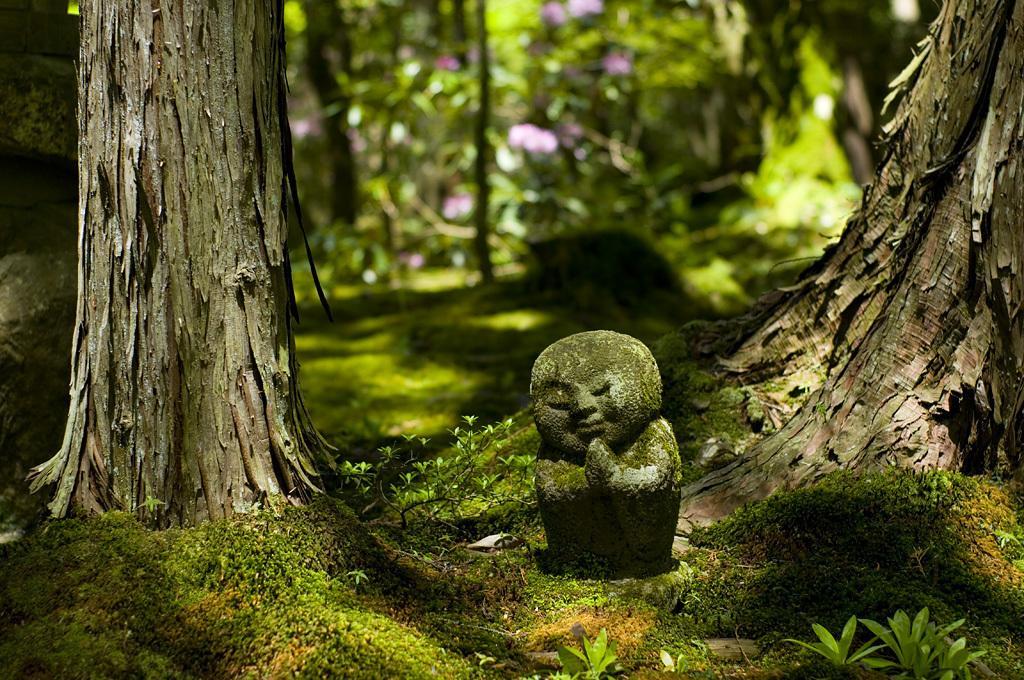In one or two sentences, can you explain what this image depicts? This picture shows trees and we see a carved stone and grass on the ground. 